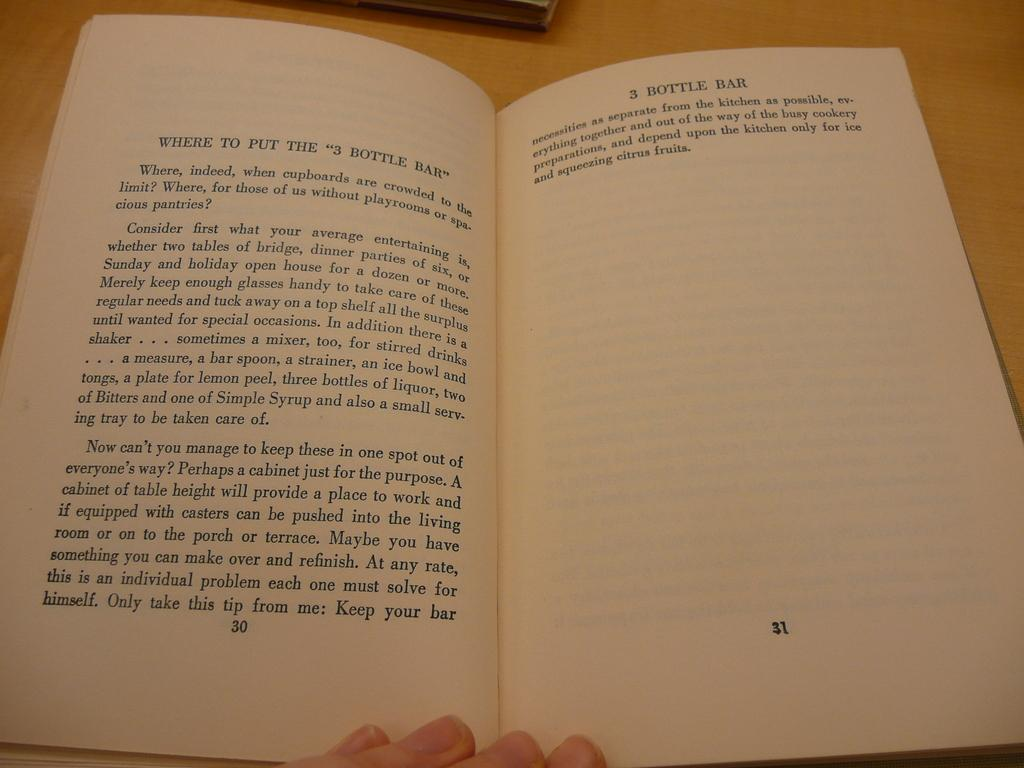<image>
Present a compact description of the photo's key features. The right page of the opened book says 3 bottle bar. 